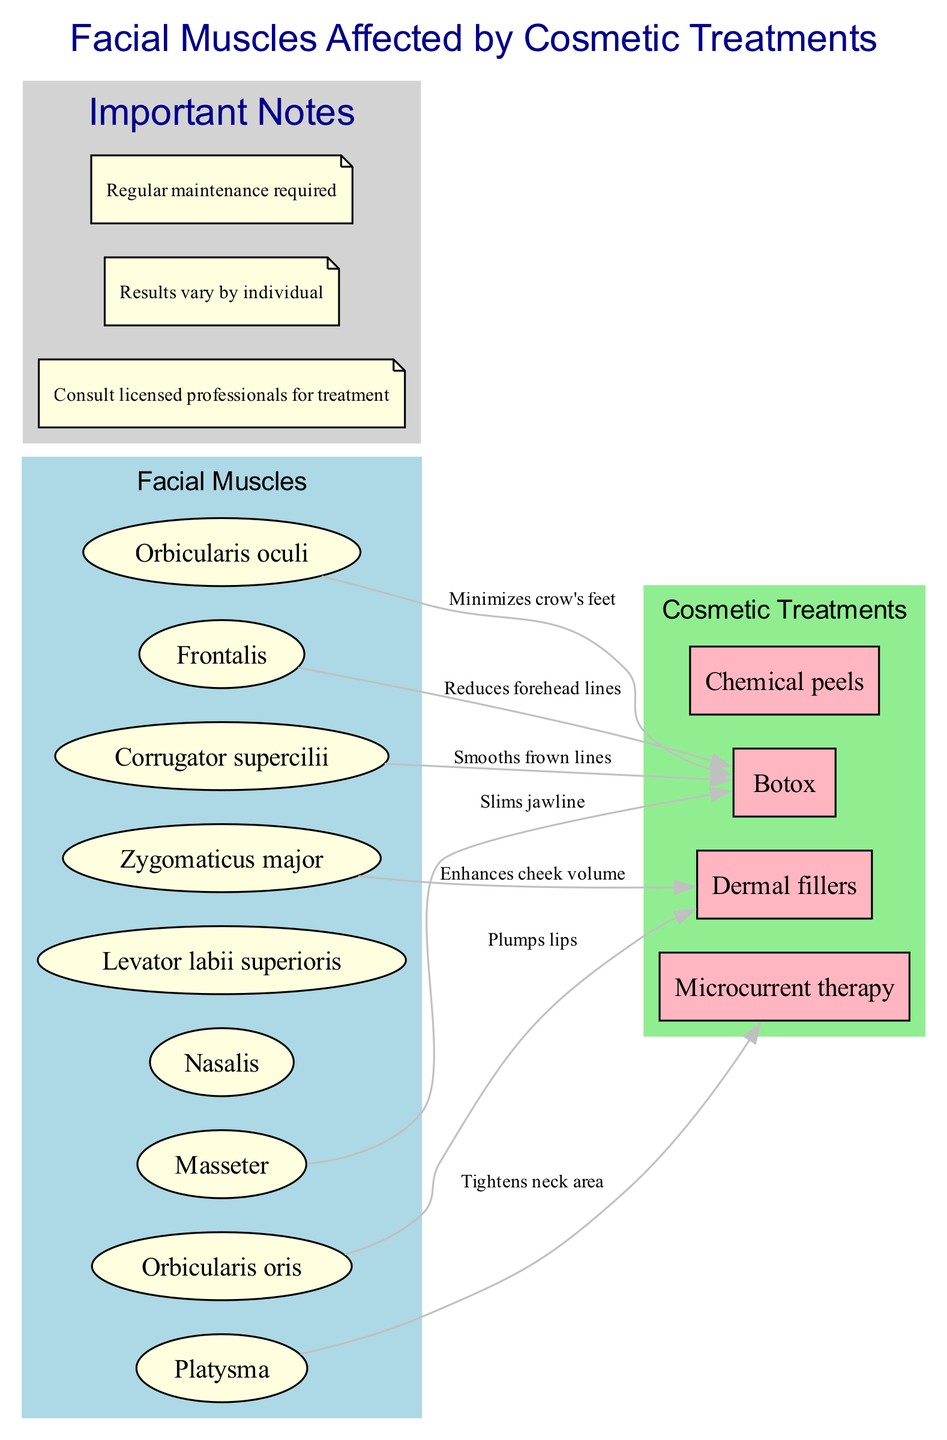What is the main focus of the diagram? The title of the diagram clearly states that it is about the facial muscles affected by cosmetic treatments. This indicates that the primary focus is on the relationship between facial muscles and various cosmetic procedures.
Answer: Facial muscles affected by cosmetic treatments How many main components are there in the diagram? By counting the entries listed under the "mainComponents" section, we can see that there are a total of nine key facial muscles depicted in the diagram.
Answer: 9 Which treatment targets the "Masseter" muscle? The diagram shows an edge leading from "Masseter" to the "Botox" treatment, indicating that Botox is the treatment used for this specific muscle.
Answer: Botox What effect does "Botox" have on the "Frontalis" muscle? The diagram outlines a relationship from "Frontalis" to "Botox," with the label stating that Botox "Reduces forehead lines," thus indicating the specific effect of this treatment on the muscle.
Answer: Reduces forehead lines Which cosmetic treatment is associated with tightening the neck area? The diagram depicts "Platysma" connected to "Microcurrent therapy," with the effect labeled as "Tightens neck area." This shows that Microcurrent therapy is the treatment that addresses this concern.
Answer: Microcurrent therapy What is the relationship between "Zygomaticus major" and "Dermal fillers"? The diagram illustrates an edge connecting "Zygomaticus major" to "Dermal fillers," with the effect described as "Enhances cheek volume," indicating a direct relationship and effect of this treatment on the muscle.
Answer: Enhances cheek volume How many treatments are represented in the diagram? In the "treatments" section, there are four different treatments listed that connect to various facial muscles, confirming that the diagram features a total of four distinct treatments.
Answer: 4 Which muscle is affected by "Dermal fillers" according to the diagram? The connections section of the diagram shows that "Orbicularis oris" is connected to "Dermal fillers," indicating that this particular muscle is affected by that treatment.
Answer: Orbicularis oris What does the diagram recommend about treatment consultations? The notes section of the diagram gives us important information, stating, "Consult licensed professionals for treatment," which indicates the recommended course of action regarding cosmetic treatments.
Answer: Consult licensed professionals for treatment 